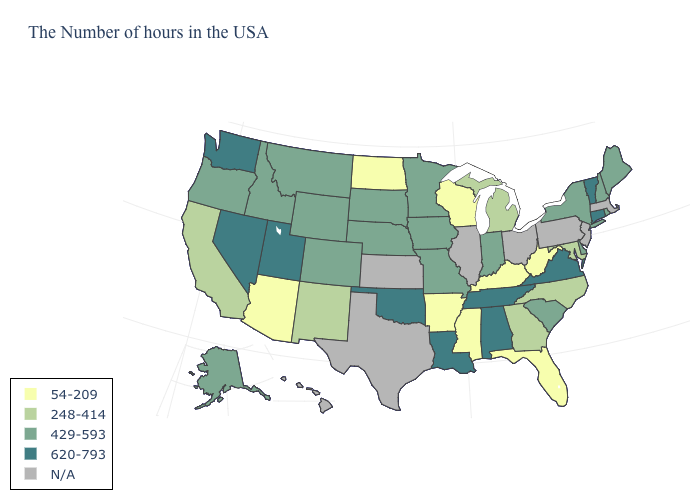How many symbols are there in the legend?
Be succinct. 5. Which states have the lowest value in the USA?
Concise answer only. West Virginia, Florida, Kentucky, Wisconsin, Mississippi, Arkansas, North Dakota, Arizona. What is the value of Maine?
Give a very brief answer. 429-593. Name the states that have a value in the range 54-209?
Keep it brief. West Virginia, Florida, Kentucky, Wisconsin, Mississippi, Arkansas, North Dakota, Arizona. Does Louisiana have the lowest value in the South?
Answer briefly. No. What is the lowest value in the USA?
Be succinct. 54-209. Does South Dakota have the highest value in the MidWest?
Keep it brief. Yes. Does the map have missing data?
Short answer required. Yes. Does the map have missing data?
Concise answer only. Yes. Which states have the lowest value in the West?
Answer briefly. Arizona. Which states have the highest value in the USA?
Answer briefly. Vermont, Connecticut, Virginia, Alabama, Tennessee, Louisiana, Oklahoma, Utah, Nevada, Washington. How many symbols are there in the legend?
Concise answer only. 5. Name the states that have a value in the range 620-793?
Short answer required. Vermont, Connecticut, Virginia, Alabama, Tennessee, Louisiana, Oklahoma, Utah, Nevada, Washington. Among the states that border Georgia , which have the lowest value?
Give a very brief answer. Florida. 